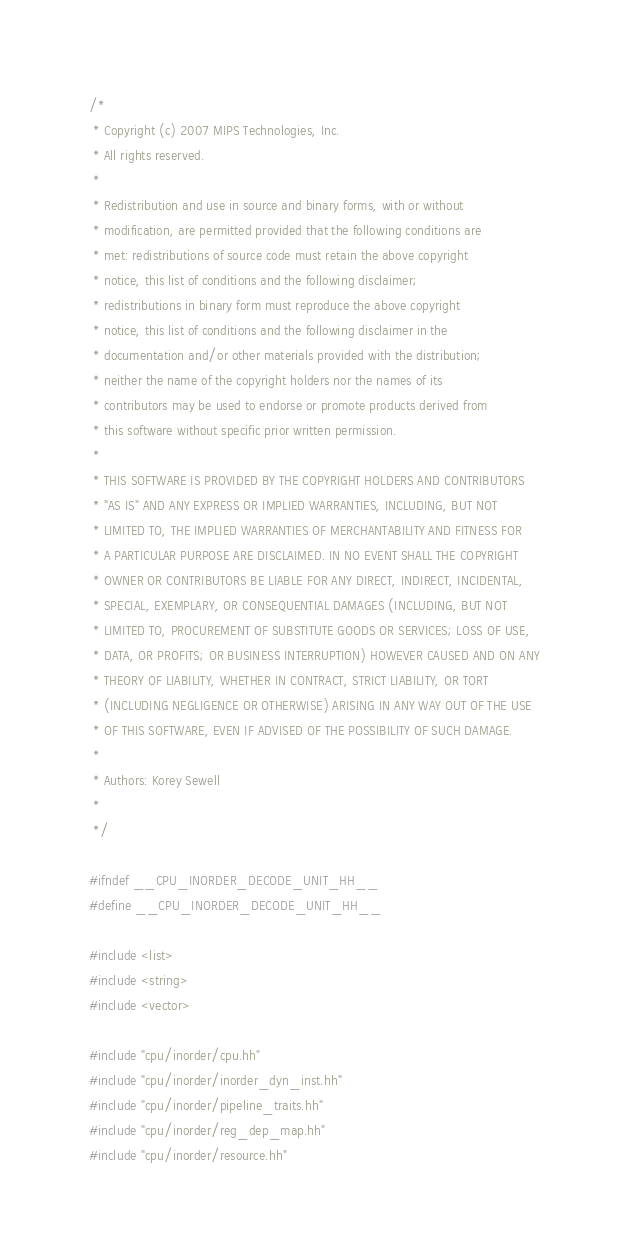Convert code to text. <code><loc_0><loc_0><loc_500><loc_500><_C++_>/*
 * Copyright (c) 2007 MIPS Technologies, Inc.
 * All rights reserved.
 *
 * Redistribution and use in source and binary forms, with or without
 * modification, are permitted provided that the following conditions are
 * met: redistributions of source code must retain the above copyright
 * notice, this list of conditions and the following disclaimer;
 * redistributions in binary form must reproduce the above copyright
 * notice, this list of conditions and the following disclaimer in the
 * documentation and/or other materials provided with the distribution;
 * neither the name of the copyright holders nor the names of its
 * contributors may be used to endorse or promote products derived from
 * this software without specific prior written permission.
 *
 * THIS SOFTWARE IS PROVIDED BY THE COPYRIGHT HOLDERS AND CONTRIBUTORS
 * "AS IS" AND ANY EXPRESS OR IMPLIED WARRANTIES, INCLUDING, BUT NOT
 * LIMITED TO, THE IMPLIED WARRANTIES OF MERCHANTABILITY AND FITNESS FOR
 * A PARTICULAR PURPOSE ARE DISCLAIMED. IN NO EVENT SHALL THE COPYRIGHT
 * OWNER OR CONTRIBUTORS BE LIABLE FOR ANY DIRECT, INDIRECT, INCIDENTAL,
 * SPECIAL, EXEMPLARY, OR CONSEQUENTIAL DAMAGES (INCLUDING, BUT NOT
 * LIMITED TO, PROCUREMENT OF SUBSTITUTE GOODS OR SERVICES; LOSS OF USE,
 * DATA, OR PROFITS; OR BUSINESS INTERRUPTION) HOWEVER CAUSED AND ON ANY
 * THEORY OF LIABILITY, WHETHER IN CONTRACT, STRICT LIABILITY, OR TORT
 * (INCLUDING NEGLIGENCE OR OTHERWISE) ARISING IN ANY WAY OUT OF THE USE
 * OF THIS SOFTWARE, EVEN IF ADVISED OF THE POSSIBILITY OF SUCH DAMAGE.
 *
 * Authors: Korey Sewell
 *
 */

#ifndef __CPU_INORDER_DECODE_UNIT_HH__
#define __CPU_INORDER_DECODE_UNIT_HH__

#include <list>
#include <string>
#include <vector>

#include "cpu/inorder/cpu.hh"
#include "cpu/inorder/inorder_dyn_inst.hh"
#include "cpu/inorder/pipeline_traits.hh"
#include "cpu/inorder/reg_dep_map.hh"
#include "cpu/inorder/resource.hh"
</code> 